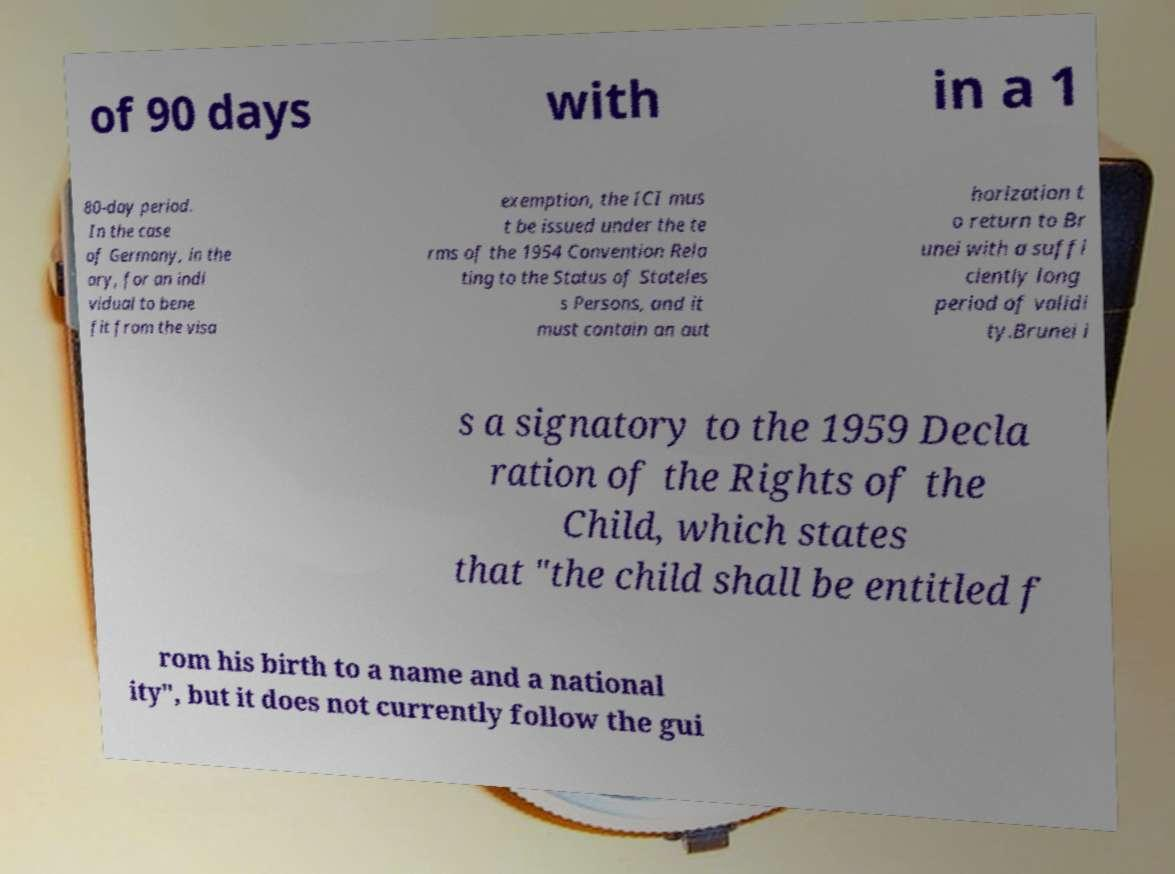Can you accurately transcribe the text from the provided image for me? of 90 days with in a 1 80-day period. In the case of Germany, in the ory, for an indi vidual to bene fit from the visa exemption, the ICI mus t be issued under the te rms of the 1954 Convention Rela ting to the Status of Stateles s Persons, and it must contain an aut horization t o return to Br unei with a suffi ciently long period of validi ty.Brunei i s a signatory to the 1959 Decla ration of the Rights of the Child, which states that "the child shall be entitled f rom his birth to a name and a national ity", but it does not currently follow the gui 